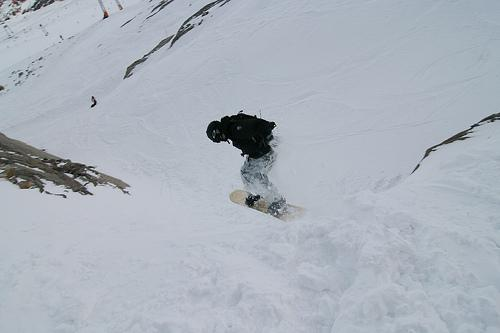Question: who is on the snowboard?
Choices:
A. A teenager.
B. A man.
C. A boy.
D. A lady.
Answer with the letter. Answer: B Question: what is the man standing on?
Choices:
A. Cement block.
B. Skateboard.
C. Steps.
D. Snowboard.
Answer with the letter. Answer: D Question: what color jacket is the snowboarder wearing?
Choices:
A. Black.
B. Blue.
C. Brown.
D. Red.
Answer with the letter. Answer: A Question: what is covering the ground?
Choices:
A. Grass.
B. Leaves.
C. Frost.
D. Snow.
Answer with the letter. Answer: D Question: why is the snowboarder leaning over?
Choices:
A. Sliding in the snow.
B. To balance.
C. To break fall.
D. To keep snow out of eyes.
Answer with the letter. Answer: A 